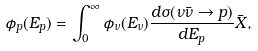<formula> <loc_0><loc_0><loc_500><loc_500>\phi _ { p } ( E _ { p } ) = \int _ { 0 } ^ { \infty } \phi _ { \nu } ( E _ { \nu } ) \frac { d \sigma ( \nu \bar { \nu } \rightarrow p ) } { d E _ { p } } \bar { X } ,</formula> 